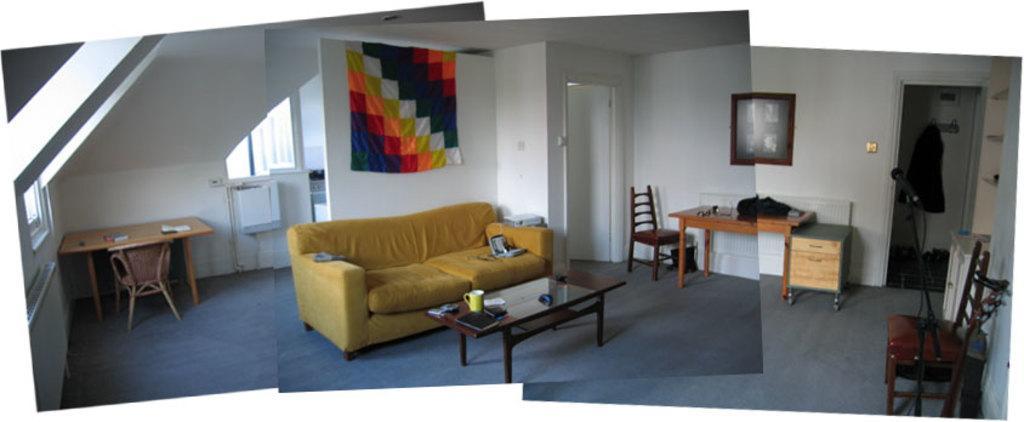Please provide a concise description of this image. This image is clicked in a room. There is sofa and table in the middle, on that table there are cups, book, on the sofa there are cushions. There is table and chair placed on the left side ,there is book on that table. There are Windows on the left side. there is a cloth placed in the middle. There are table and chairs on the right side too and there is a room on the right side ,there is a chair and mike on the right side. There is a photo frame in the middle. 